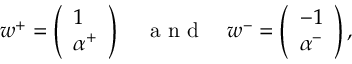Convert formula to latex. <formula><loc_0><loc_0><loc_500><loc_500>\begin{array} { r } { w ^ { + } = \left ( \begin{array} { l } { 1 } \\ { \alpha ^ { + } } \end{array} \right ) \quad a n d \quad w ^ { - } = \left ( \begin{array} { l } { - 1 } \\ { \alpha ^ { - } } \end{array} \right ) , } \end{array}</formula> 